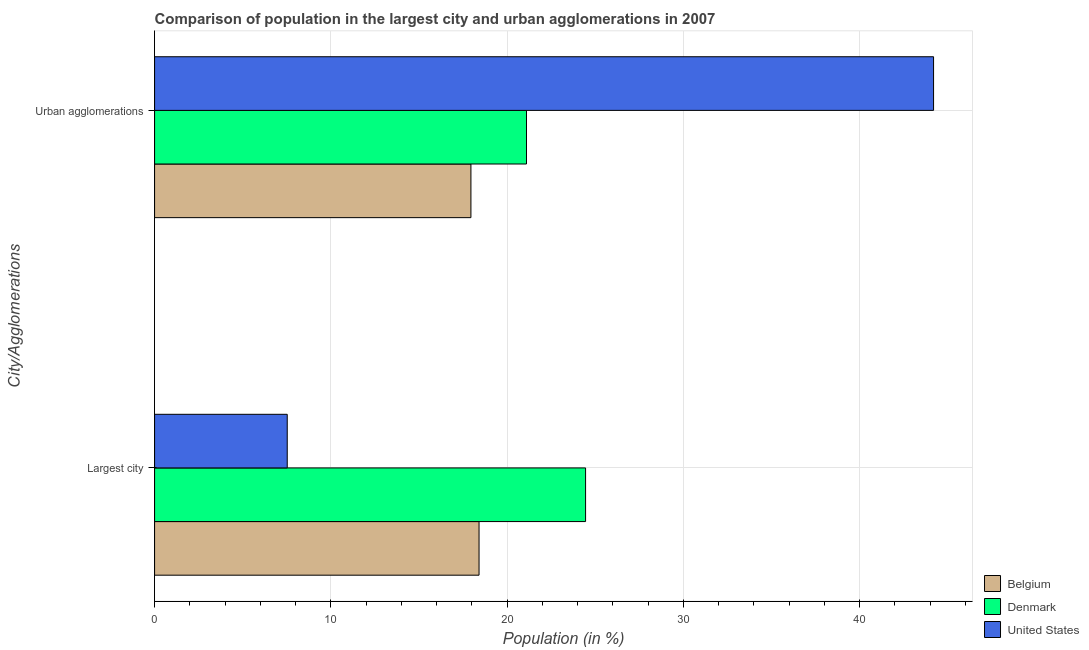How many bars are there on the 1st tick from the top?
Offer a terse response. 3. How many bars are there on the 1st tick from the bottom?
Offer a terse response. 3. What is the label of the 2nd group of bars from the top?
Give a very brief answer. Largest city. What is the population in urban agglomerations in Belgium?
Offer a terse response. 17.95. Across all countries, what is the maximum population in urban agglomerations?
Your answer should be very brief. 44.19. Across all countries, what is the minimum population in the largest city?
Provide a short and direct response. 7.53. In which country was the population in urban agglomerations maximum?
Your response must be concise. United States. In which country was the population in the largest city minimum?
Offer a very short reply. United States. What is the total population in the largest city in the graph?
Keep it short and to the point. 50.38. What is the difference between the population in the largest city in Denmark and that in United States?
Provide a succinct answer. 16.92. What is the difference between the population in the largest city in Belgium and the population in urban agglomerations in Denmark?
Your answer should be compact. -2.69. What is the average population in the largest city per country?
Provide a succinct answer. 16.79. What is the difference between the population in urban agglomerations and population in the largest city in Belgium?
Offer a very short reply. -0.46. What is the ratio of the population in urban agglomerations in United States to that in Denmark?
Keep it short and to the point. 2.09. Is the population in urban agglomerations in Belgium less than that in Denmark?
Provide a succinct answer. Yes. What does the 1st bar from the bottom in Largest city represents?
Provide a short and direct response. Belgium. Are the values on the major ticks of X-axis written in scientific E-notation?
Your response must be concise. No. Does the graph contain any zero values?
Make the answer very short. No. Where does the legend appear in the graph?
Your response must be concise. Bottom right. How many legend labels are there?
Offer a terse response. 3. What is the title of the graph?
Your response must be concise. Comparison of population in the largest city and urban agglomerations in 2007. What is the label or title of the X-axis?
Offer a very short reply. Population (in %). What is the label or title of the Y-axis?
Provide a succinct answer. City/Agglomerations. What is the Population (in %) in Belgium in Largest city?
Keep it short and to the point. 18.41. What is the Population (in %) of Denmark in Largest city?
Make the answer very short. 24.45. What is the Population (in %) in United States in Largest city?
Keep it short and to the point. 7.53. What is the Population (in %) of Belgium in Urban agglomerations?
Offer a very short reply. 17.95. What is the Population (in %) in Denmark in Urban agglomerations?
Provide a short and direct response. 21.1. What is the Population (in %) in United States in Urban agglomerations?
Provide a succinct answer. 44.19. Across all City/Agglomerations, what is the maximum Population (in %) in Belgium?
Offer a terse response. 18.41. Across all City/Agglomerations, what is the maximum Population (in %) in Denmark?
Your answer should be very brief. 24.45. Across all City/Agglomerations, what is the maximum Population (in %) of United States?
Give a very brief answer. 44.19. Across all City/Agglomerations, what is the minimum Population (in %) of Belgium?
Your answer should be very brief. 17.95. Across all City/Agglomerations, what is the minimum Population (in %) of Denmark?
Your response must be concise. 21.1. Across all City/Agglomerations, what is the minimum Population (in %) in United States?
Make the answer very short. 7.53. What is the total Population (in %) of Belgium in the graph?
Offer a very short reply. 36.35. What is the total Population (in %) of Denmark in the graph?
Your response must be concise. 45.55. What is the total Population (in %) in United States in the graph?
Offer a terse response. 51.72. What is the difference between the Population (in %) in Belgium in Largest city and that in Urban agglomerations?
Provide a succinct answer. 0.46. What is the difference between the Population (in %) of Denmark in Largest city and that in Urban agglomerations?
Provide a short and direct response. 3.35. What is the difference between the Population (in %) in United States in Largest city and that in Urban agglomerations?
Your response must be concise. -36.66. What is the difference between the Population (in %) in Belgium in Largest city and the Population (in %) in Denmark in Urban agglomerations?
Your answer should be very brief. -2.69. What is the difference between the Population (in %) of Belgium in Largest city and the Population (in %) of United States in Urban agglomerations?
Your answer should be compact. -25.78. What is the difference between the Population (in %) of Denmark in Largest city and the Population (in %) of United States in Urban agglomerations?
Your response must be concise. -19.74. What is the average Population (in %) of Belgium per City/Agglomerations?
Offer a very short reply. 18.18. What is the average Population (in %) of Denmark per City/Agglomerations?
Provide a short and direct response. 22.77. What is the average Population (in %) of United States per City/Agglomerations?
Give a very brief answer. 25.86. What is the difference between the Population (in %) in Belgium and Population (in %) in Denmark in Largest city?
Offer a terse response. -6.04. What is the difference between the Population (in %) in Belgium and Population (in %) in United States in Largest city?
Your answer should be very brief. 10.88. What is the difference between the Population (in %) in Denmark and Population (in %) in United States in Largest city?
Offer a terse response. 16.92. What is the difference between the Population (in %) of Belgium and Population (in %) of Denmark in Urban agglomerations?
Ensure brevity in your answer.  -3.15. What is the difference between the Population (in %) of Belgium and Population (in %) of United States in Urban agglomerations?
Ensure brevity in your answer.  -26.24. What is the difference between the Population (in %) in Denmark and Population (in %) in United States in Urban agglomerations?
Keep it short and to the point. -23.09. What is the ratio of the Population (in %) in Belgium in Largest city to that in Urban agglomerations?
Your response must be concise. 1.03. What is the ratio of the Population (in %) in Denmark in Largest city to that in Urban agglomerations?
Give a very brief answer. 1.16. What is the ratio of the Population (in %) in United States in Largest city to that in Urban agglomerations?
Give a very brief answer. 0.17. What is the difference between the highest and the second highest Population (in %) in Belgium?
Provide a succinct answer. 0.46. What is the difference between the highest and the second highest Population (in %) in Denmark?
Give a very brief answer. 3.35. What is the difference between the highest and the second highest Population (in %) of United States?
Offer a terse response. 36.66. What is the difference between the highest and the lowest Population (in %) in Belgium?
Provide a succinct answer. 0.46. What is the difference between the highest and the lowest Population (in %) of Denmark?
Provide a succinct answer. 3.35. What is the difference between the highest and the lowest Population (in %) of United States?
Give a very brief answer. 36.66. 